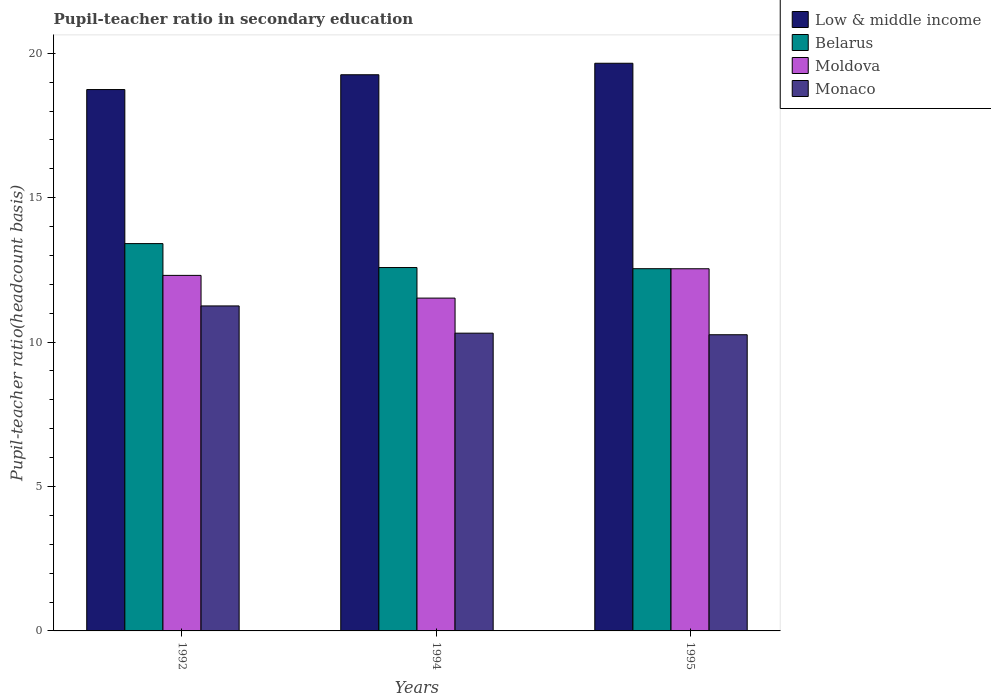How many groups of bars are there?
Your answer should be compact. 3. Are the number of bars per tick equal to the number of legend labels?
Your answer should be compact. Yes. How many bars are there on the 1st tick from the left?
Your answer should be compact. 4. What is the label of the 2nd group of bars from the left?
Provide a short and direct response. 1994. In how many cases, is the number of bars for a given year not equal to the number of legend labels?
Provide a succinct answer. 0. What is the pupil-teacher ratio in secondary education in Belarus in 1994?
Make the answer very short. 12.58. Across all years, what is the maximum pupil-teacher ratio in secondary education in Belarus?
Offer a terse response. 13.41. Across all years, what is the minimum pupil-teacher ratio in secondary education in Low & middle income?
Provide a succinct answer. 18.74. In which year was the pupil-teacher ratio in secondary education in Moldova maximum?
Give a very brief answer. 1995. In which year was the pupil-teacher ratio in secondary education in Monaco minimum?
Your answer should be very brief. 1995. What is the total pupil-teacher ratio in secondary education in Belarus in the graph?
Give a very brief answer. 38.53. What is the difference between the pupil-teacher ratio in secondary education in Moldova in 1992 and that in 1995?
Give a very brief answer. -0.23. What is the difference between the pupil-teacher ratio in secondary education in Belarus in 1992 and the pupil-teacher ratio in secondary education in Moldova in 1994?
Provide a short and direct response. 1.89. What is the average pupil-teacher ratio in secondary education in Low & middle income per year?
Provide a succinct answer. 19.22. In the year 1995, what is the difference between the pupil-teacher ratio in secondary education in Moldova and pupil-teacher ratio in secondary education in Monaco?
Your answer should be very brief. 2.28. In how many years, is the pupil-teacher ratio in secondary education in Moldova greater than 12?
Give a very brief answer. 2. What is the ratio of the pupil-teacher ratio in secondary education in Low & middle income in 1992 to that in 1995?
Your answer should be very brief. 0.95. What is the difference between the highest and the second highest pupil-teacher ratio in secondary education in Low & middle income?
Provide a succinct answer. 0.4. What is the difference between the highest and the lowest pupil-teacher ratio in secondary education in Monaco?
Your answer should be compact. 1. In how many years, is the pupil-teacher ratio in secondary education in Belarus greater than the average pupil-teacher ratio in secondary education in Belarus taken over all years?
Keep it short and to the point. 1. What does the 3rd bar from the right in 1992 represents?
Your response must be concise. Belarus. Is it the case that in every year, the sum of the pupil-teacher ratio in secondary education in Moldova and pupil-teacher ratio in secondary education in Belarus is greater than the pupil-teacher ratio in secondary education in Low & middle income?
Ensure brevity in your answer.  Yes. How many bars are there?
Ensure brevity in your answer.  12. Are all the bars in the graph horizontal?
Make the answer very short. No. Does the graph contain any zero values?
Ensure brevity in your answer.  No. Does the graph contain grids?
Provide a succinct answer. No. What is the title of the graph?
Your response must be concise. Pupil-teacher ratio in secondary education. Does "European Union" appear as one of the legend labels in the graph?
Your answer should be very brief. No. What is the label or title of the X-axis?
Give a very brief answer. Years. What is the label or title of the Y-axis?
Keep it short and to the point. Pupil-teacher ratio(headcount basis). What is the Pupil-teacher ratio(headcount basis) in Low & middle income in 1992?
Give a very brief answer. 18.74. What is the Pupil-teacher ratio(headcount basis) in Belarus in 1992?
Ensure brevity in your answer.  13.41. What is the Pupil-teacher ratio(headcount basis) in Moldova in 1992?
Your answer should be very brief. 12.31. What is the Pupil-teacher ratio(headcount basis) of Monaco in 1992?
Provide a short and direct response. 11.25. What is the Pupil-teacher ratio(headcount basis) of Low & middle income in 1994?
Make the answer very short. 19.26. What is the Pupil-teacher ratio(headcount basis) of Belarus in 1994?
Your response must be concise. 12.58. What is the Pupil-teacher ratio(headcount basis) of Moldova in 1994?
Your response must be concise. 11.52. What is the Pupil-teacher ratio(headcount basis) in Monaco in 1994?
Keep it short and to the point. 10.31. What is the Pupil-teacher ratio(headcount basis) of Low & middle income in 1995?
Your answer should be very brief. 19.65. What is the Pupil-teacher ratio(headcount basis) in Belarus in 1995?
Give a very brief answer. 12.54. What is the Pupil-teacher ratio(headcount basis) of Moldova in 1995?
Give a very brief answer. 12.54. What is the Pupil-teacher ratio(headcount basis) of Monaco in 1995?
Give a very brief answer. 10.25. Across all years, what is the maximum Pupil-teacher ratio(headcount basis) in Low & middle income?
Ensure brevity in your answer.  19.65. Across all years, what is the maximum Pupil-teacher ratio(headcount basis) of Belarus?
Your answer should be compact. 13.41. Across all years, what is the maximum Pupil-teacher ratio(headcount basis) of Moldova?
Ensure brevity in your answer.  12.54. Across all years, what is the maximum Pupil-teacher ratio(headcount basis) of Monaco?
Provide a short and direct response. 11.25. Across all years, what is the minimum Pupil-teacher ratio(headcount basis) in Low & middle income?
Provide a succinct answer. 18.74. Across all years, what is the minimum Pupil-teacher ratio(headcount basis) in Belarus?
Offer a very short reply. 12.54. Across all years, what is the minimum Pupil-teacher ratio(headcount basis) of Moldova?
Ensure brevity in your answer.  11.52. Across all years, what is the minimum Pupil-teacher ratio(headcount basis) of Monaco?
Provide a succinct answer. 10.25. What is the total Pupil-teacher ratio(headcount basis) of Low & middle income in the graph?
Your response must be concise. 57.65. What is the total Pupil-teacher ratio(headcount basis) of Belarus in the graph?
Provide a short and direct response. 38.53. What is the total Pupil-teacher ratio(headcount basis) of Moldova in the graph?
Provide a short and direct response. 36.37. What is the total Pupil-teacher ratio(headcount basis) of Monaco in the graph?
Your answer should be very brief. 31.82. What is the difference between the Pupil-teacher ratio(headcount basis) of Low & middle income in 1992 and that in 1994?
Offer a very short reply. -0.51. What is the difference between the Pupil-teacher ratio(headcount basis) in Belarus in 1992 and that in 1994?
Provide a succinct answer. 0.83. What is the difference between the Pupil-teacher ratio(headcount basis) of Moldova in 1992 and that in 1994?
Keep it short and to the point. 0.79. What is the difference between the Pupil-teacher ratio(headcount basis) in Monaco in 1992 and that in 1994?
Ensure brevity in your answer.  0.94. What is the difference between the Pupil-teacher ratio(headcount basis) of Low & middle income in 1992 and that in 1995?
Give a very brief answer. -0.91. What is the difference between the Pupil-teacher ratio(headcount basis) in Belarus in 1992 and that in 1995?
Make the answer very short. 0.87. What is the difference between the Pupil-teacher ratio(headcount basis) of Moldova in 1992 and that in 1995?
Offer a very short reply. -0.23. What is the difference between the Pupil-teacher ratio(headcount basis) of Monaco in 1992 and that in 1995?
Ensure brevity in your answer.  1. What is the difference between the Pupil-teacher ratio(headcount basis) in Low & middle income in 1994 and that in 1995?
Provide a short and direct response. -0.4. What is the difference between the Pupil-teacher ratio(headcount basis) in Moldova in 1994 and that in 1995?
Offer a terse response. -1.02. What is the difference between the Pupil-teacher ratio(headcount basis) in Monaco in 1994 and that in 1995?
Provide a succinct answer. 0.05. What is the difference between the Pupil-teacher ratio(headcount basis) in Low & middle income in 1992 and the Pupil-teacher ratio(headcount basis) in Belarus in 1994?
Offer a very short reply. 6.16. What is the difference between the Pupil-teacher ratio(headcount basis) of Low & middle income in 1992 and the Pupil-teacher ratio(headcount basis) of Moldova in 1994?
Your answer should be compact. 7.22. What is the difference between the Pupil-teacher ratio(headcount basis) of Low & middle income in 1992 and the Pupil-teacher ratio(headcount basis) of Monaco in 1994?
Make the answer very short. 8.43. What is the difference between the Pupil-teacher ratio(headcount basis) in Belarus in 1992 and the Pupil-teacher ratio(headcount basis) in Moldova in 1994?
Offer a terse response. 1.89. What is the difference between the Pupil-teacher ratio(headcount basis) of Belarus in 1992 and the Pupil-teacher ratio(headcount basis) of Monaco in 1994?
Make the answer very short. 3.1. What is the difference between the Pupil-teacher ratio(headcount basis) of Moldova in 1992 and the Pupil-teacher ratio(headcount basis) of Monaco in 1994?
Provide a short and direct response. 2. What is the difference between the Pupil-teacher ratio(headcount basis) in Low & middle income in 1992 and the Pupil-teacher ratio(headcount basis) in Belarus in 1995?
Keep it short and to the point. 6.2. What is the difference between the Pupil-teacher ratio(headcount basis) of Low & middle income in 1992 and the Pupil-teacher ratio(headcount basis) of Moldova in 1995?
Your response must be concise. 6.2. What is the difference between the Pupil-teacher ratio(headcount basis) in Low & middle income in 1992 and the Pupil-teacher ratio(headcount basis) in Monaco in 1995?
Make the answer very short. 8.49. What is the difference between the Pupil-teacher ratio(headcount basis) in Belarus in 1992 and the Pupil-teacher ratio(headcount basis) in Moldova in 1995?
Keep it short and to the point. 0.87. What is the difference between the Pupil-teacher ratio(headcount basis) in Belarus in 1992 and the Pupil-teacher ratio(headcount basis) in Monaco in 1995?
Your answer should be compact. 3.16. What is the difference between the Pupil-teacher ratio(headcount basis) of Moldova in 1992 and the Pupil-teacher ratio(headcount basis) of Monaco in 1995?
Offer a very short reply. 2.06. What is the difference between the Pupil-teacher ratio(headcount basis) in Low & middle income in 1994 and the Pupil-teacher ratio(headcount basis) in Belarus in 1995?
Offer a terse response. 6.71. What is the difference between the Pupil-teacher ratio(headcount basis) of Low & middle income in 1994 and the Pupil-teacher ratio(headcount basis) of Moldova in 1995?
Ensure brevity in your answer.  6.72. What is the difference between the Pupil-teacher ratio(headcount basis) of Low & middle income in 1994 and the Pupil-teacher ratio(headcount basis) of Monaco in 1995?
Provide a short and direct response. 9. What is the difference between the Pupil-teacher ratio(headcount basis) of Belarus in 1994 and the Pupil-teacher ratio(headcount basis) of Moldova in 1995?
Offer a very short reply. 0.04. What is the difference between the Pupil-teacher ratio(headcount basis) of Belarus in 1994 and the Pupil-teacher ratio(headcount basis) of Monaco in 1995?
Provide a short and direct response. 2.33. What is the difference between the Pupil-teacher ratio(headcount basis) of Moldova in 1994 and the Pupil-teacher ratio(headcount basis) of Monaco in 1995?
Provide a succinct answer. 1.27. What is the average Pupil-teacher ratio(headcount basis) of Low & middle income per year?
Ensure brevity in your answer.  19.22. What is the average Pupil-teacher ratio(headcount basis) in Belarus per year?
Keep it short and to the point. 12.84. What is the average Pupil-teacher ratio(headcount basis) in Moldova per year?
Give a very brief answer. 12.12. What is the average Pupil-teacher ratio(headcount basis) of Monaco per year?
Ensure brevity in your answer.  10.61. In the year 1992, what is the difference between the Pupil-teacher ratio(headcount basis) of Low & middle income and Pupil-teacher ratio(headcount basis) of Belarus?
Your answer should be very brief. 5.33. In the year 1992, what is the difference between the Pupil-teacher ratio(headcount basis) of Low & middle income and Pupil-teacher ratio(headcount basis) of Moldova?
Keep it short and to the point. 6.43. In the year 1992, what is the difference between the Pupil-teacher ratio(headcount basis) of Low & middle income and Pupil-teacher ratio(headcount basis) of Monaco?
Provide a succinct answer. 7.49. In the year 1992, what is the difference between the Pupil-teacher ratio(headcount basis) in Belarus and Pupil-teacher ratio(headcount basis) in Moldova?
Give a very brief answer. 1.1. In the year 1992, what is the difference between the Pupil-teacher ratio(headcount basis) in Belarus and Pupil-teacher ratio(headcount basis) in Monaco?
Offer a terse response. 2.16. In the year 1992, what is the difference between the Pupil-teacher ratio(headcount basis) of Moldova and Pupil-teacher ratio(headcount basis) of Monaco?
Provide a succinct answer. 1.06. In the year 1994, what is the difference between the Pupil-teacher ratio(headcount basis) of Low & middle income and Pupil-teacher ratio(headcount basis) of Belarus?
Provide a short and direct response. 6.67. In the year 1994, what is the difference between the Pupil-teacher ratio(headcount basis) of Low & middle income and Pupil-teacher ratio(headcount basis) of Moldova?
Provide a succinct answer. 7.73. In the year 1994, what is the difference between the Pupil-teacher ratio(headcount basis) in Low & middle income and Pupil-teacher ratio(headcount basis) in Monaco?
Provide a succinct answer. 8.95. In the year 1994, what is the difference between the Pupil-teacher ratio(headcount basis) in Belarus and Pupil-teacher ratio(headcount basis) in Moldova?
Offer a very short reply. 1.06. In the year 1994, what is the difference between the Pupil-teacher ratio(headcount basis) in Belarus and Pupil-teacher ratio(headcount basis) in Monaco?
Your response must be concise. 2.27. In the year 1994, what is the difference between the Pupil-teacher ratio(headcount basis) in Moldova and Pupil-teacher ratio(headcount basis) in Monaco?
Offer a terse response. 1.21. In the year 1995, what is the difference between the Pupil-teacher ratio(headcount basis) of Low & middle income and Pupil-teacher ratio(headcount basis) of Belarus?
Keep it short and to the point. 7.11. In the year 1995, what is the difference between the Pupil-teacher ratio(headcount basis) of Low & middle income and Pupil-teacher ratio(headcount basis) of Moldova?
Your response must be concise. 7.11. In the year 1995, what is the difference between the Pupil-teacher ratio(headcount basis) of Low & middle income and Pupil-teacher ratio(headcount basis) of Monaco?
Provide a succinct answer. 9.4. In the year 1995, what is the difference between the Pupil-teacher ratio(headcount basis) of Belarus and Pupil-teacher ratio(headcount basis) of Moldova?
Ensure brevity in your answer.  0. In the year 1995, what is the difference between the Pupil-teacher ratio(headcount basis) in Belarus and Pupil-teacher ratio(headcount basis) in Monaco?
Make the answer very short. 2.29. In the year 1995, what is the difference between the Pupil-teacher ratio(headcount basis) in Moldova and Pupil-teacher ratio(headcount basis) in Monaco?
Your answer should be very brief. 2.28. What is the ratio of the Pupil-teacher ratio(headcount basis) of Low & middle income in 1992 to that in 1994?
Offer a terse response. 0.97. What is the ratio of the Pupil-teacher ratio(headcount basis) of Belarus in 1992 to that in 1994?
Your answer should be compact. 1.07. What is the ratio of the Pupil-teacher ratio(headcount basis) of Moldova in 1992 to that in 1994?
Offer a very short reply. 1.07. What is the ratio of the Pupil-teacher ratio(headcount basis) in Monaco in 1992 to that in 1994?
Your answer should be very brief. 1.09. What is the ratio of the Pupil-teacher ratio(headcount basis) in Low & middle income in 1992 to that in 1995?
Give a very brief answer. 0.95. What is the ratio of the Pupil-teacher ratio(headcount basis) in Belarus in 1992 to that in 1995?
Provide a short and direct response. 1.07. What is the ratio of the Pupil-teacher ratio(headcount basis) of Moldova in 1992 to that in 1995?
Ensure brevity in your answer.  0.98. What is the ratio of the Pupil-teacher ratio(headcount basis) of Monaco in 1992 to that in 1995?
Your answer should be compact. 1.1. What is the ratio of the Pupil-teacher ratio(headcount basis) in Low & middle income in 1994 to that in 1995?
Provide a short and direct response. 0.98. What is the ratio of the Pupil-teacher ratio(headcount basis) in Belarus in 1994 to that in 1995?
Offer a terse response. 1. What is the ratio of the Pupil-teacher ratio(headcount basis) in Moldova in 1994 to that in 1995?
Offer a terse response. 0.92. What is the ratio of the Pupil-teacher ratio(headcount basis) in Monaco in 1994 to that in 1995?
Provide a short and direct response. 1.01. What is the difference between the highest and the second highest Pupil-teacher ratio(headcount basis) in Low & middle income?
Provide a short and direct response. 0.4. What is the difference between the highest and the second highest Pupil-teacher ratio(headcount basis) of Belarus?
Ensure brevity in your answer.  0.83. What is the difference between the highest and the second highest Pupil-teacher ratio(headcount basis) in Moldova?
Keep it short and to the point. 0.23. What is the difference between the highest and the second highest Pupil-teacher ratio(headcount basis) of Monaco?
Offer a very short reply. 0.94. What is the difference between the highest and the lowest Pupil-teacher ratio(headcount basis) of Low & middle income?
Make the answer very short. 0.91. What is the difference between the highest and the lowest Pupil-teacher ratio(headcount basis) in Belarus?
Offer a very short reply. 0.87. What is the difference between the highest and the lowest Pupil-teacher ratio(headcount basis) of Moldova?
Your answer should be compact. 1.02. 